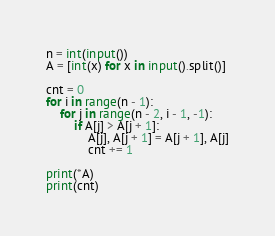Convert code to text. <code><loc_0><loc_0><loc_500><loc_500><_Python_>n = int(input())
A = [int(x) for x in input().split()]

cnt = 0
for i in range(n - 1):
    for j in range(n - 2, i - 1, -1):
        if A[j] > A[j + 1]:
            A[j], A[j + 1] = A[j + 1], A[j]
            cnt += 1

print(*A)
print(cnt)

</code> 